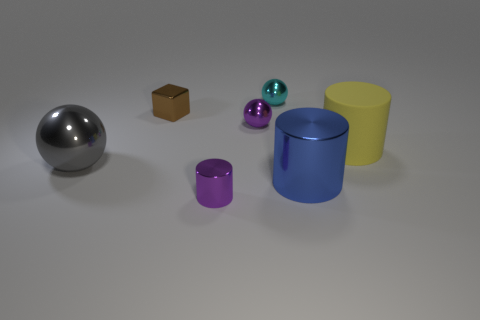What is the material texture of the object second from the left? The second object from the left seems to have a matte, cardboard-like texture, differing from the others which appear to be smooth and shiny. 